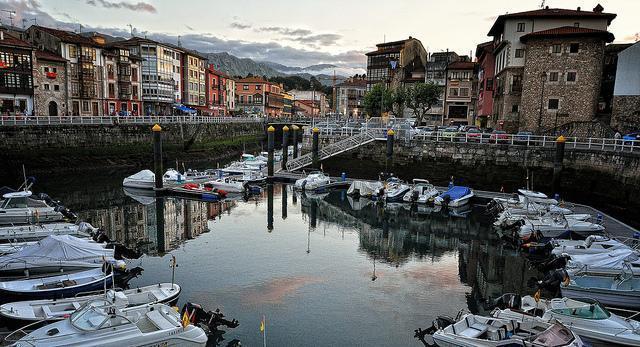How many red cars can you spot?
Give a very brief answer. 2. How many boats are in the picture?
Give a very brief answer. 7. 